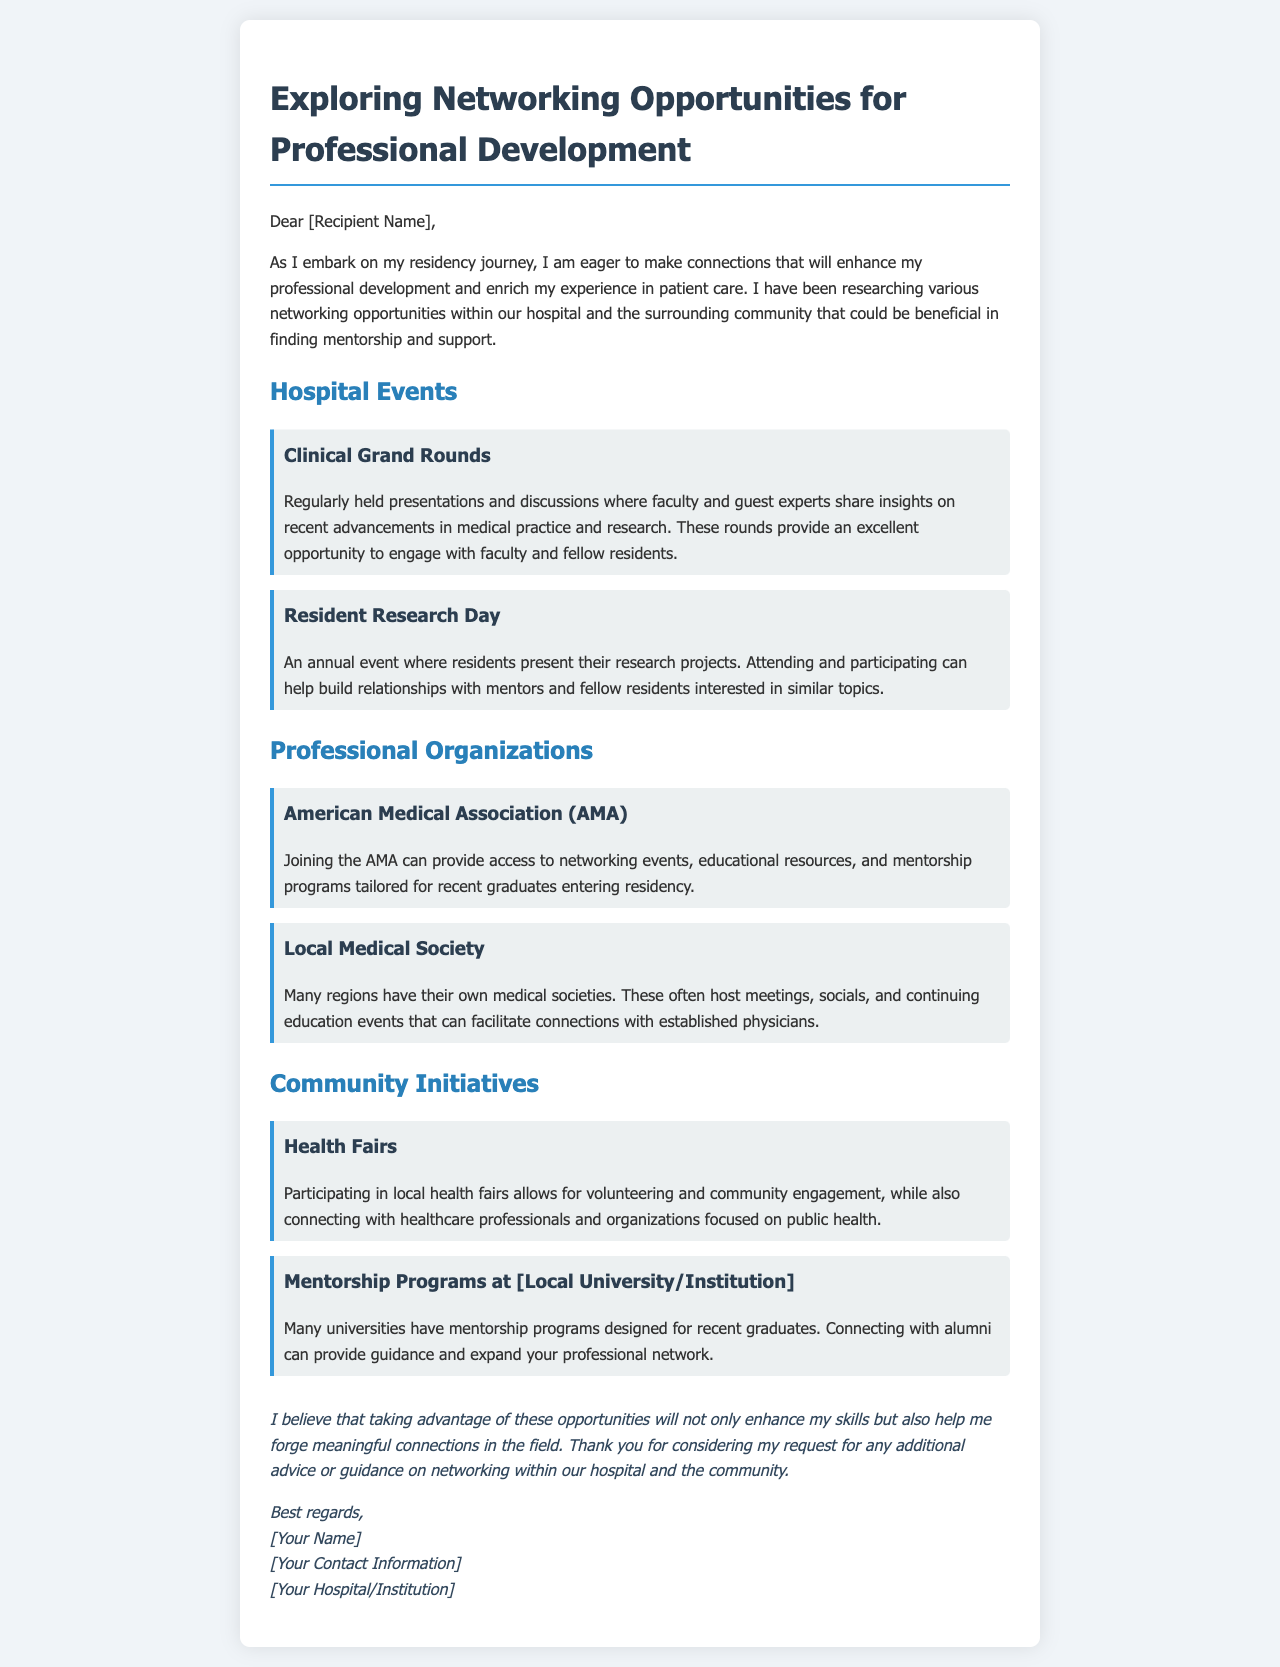What are the Clinical Grand Rounds? Clinical Grand Rounds are regularly held presentations and discussions where faculty and guest experts share insights on recent advancements in medical practice and research.
Answer: Regular presentations and discussions How often is the Resident Research Day held? The document states that Resident Research Day is an annual event.
Answer: Annual What organization provides access to networking events for recent graduates? The American Medical Association (AMA) is mentioned as providing access to networking events, educational resources, and mentorship programs.
Answer: American Medical Association (AMA) What community event allows for volunteering and engagement? Health fairs allow for volunteering and community engagement while connecting with healthcare professionals.
Answer: Health Fairs Which local institution offers mentorship programs for recent graduates? The document mentions mentorship programs designed for recent graduates at a local university or institution.
Answer: Local University/Institution What is the purpose of joining the Local Medical Society? Joining the Local Medical Society facilitates connections with established physicians through meetings, socials, and continuing education events.
Answer: Connect with established physicians What is the goal of reaching out for additional advice on networking? The goal is to seek guidance on networking within the hospital and the community.
Answer: Seek guidance Who is the intended recipient of the email? The email is addressed to a recipient whose name is specified in the greeting.
Answer: [Recipient Name] 